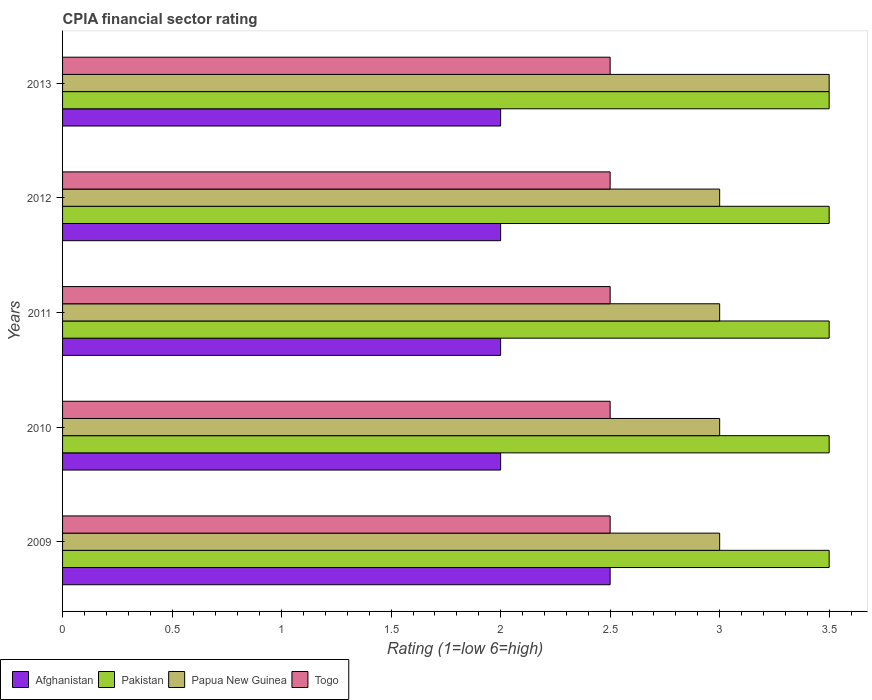How many different coloured bars are there?
Keep it short and to the point. 4. Are the number of bars per tick equal to the number of legend labels?
Offer a very short reply. Yes. Are the number of bars on each tick of the Y-axis equal?
Make the answer very short. Yes. How many bars are there on the 4th tick from the bottom?
Offer a very short reply. 4. Across all years, what is the maximum CPIA rating in Pakistan?
Provide a succinct answer. 3.5. Across all years, what is the minimum CPIA rating in Papua New Guinea?
Provide a short and direct response. 3. In which year was the CPIA rating in Afghanistan minimum?
Offer a terse response. 2010. What is the total CPIA rating in Papua New Guinea in the graph?
Offer a terse response. 15.5. What is the average CPIA rating in Afghanistan per year?
Ensure brevity in your answer.  2.1. What is the ratio of the CPIA rating in Togo in 2012 to that in 2013?
Make the answer very short. 1. Is the difference between the CPIA rating in Pakistan in 2009 and 2011 greater than the difference between the CPIA rating in Papua New Guinea in 2009 and 2011?
Ensure brevity in your answer.  No. What is the difference between the highest and the second highest CPIA rating in Papua New Guinea?
Offer a very short reply. 0.5. In how many years, is the CPIA rating in Afghanistan greater than the average CPIA rating in Afghanistan taken over all years?
Make the answer very short. 1. Is the sum of the CPIA rating in Papua New Guinea in 2009 and 2012 greater than the maximum CPIA rating in Pakistan across all years?
Give a very brief answer. Yes. Is it the case that in every year, the sum of the CPIA rating in Togo and CPIA rating in Pakistan is greater than the sum of CPIA rating in Afghanistan and CPIA rating in Papua New Guinea?
Provide a succinct answer. No. What does the 1st bar from the top in 2013 represents?
Keep it short and to the point. Togo. What does the 4th bar from the bottom in 2010 represents?
Ensure brevity in your answer.  Togo. How many bars are there?
Your response must be concise. 20. What is the difference between two consecutive major ticks on the X-axis?
Provide a short and direct response. 0.5. How many legend labels are there?
Make the answer very short. 4. How are the legend labels stacked?
Your response must be concise. Horizontal. What is the title of the graph?
Offer a very short reply. CPIA financial sector rating. Does "Poland" appear as one of the legend labels in the graph?
Give a very brief answer. No. What is the label or title of the Y-axis?
Provide a short and direct response. Years. What is the Rating (1=low 6=high) in Pakistan in 2009?
Make the answer very short. 3.5. What is the Rating (1=low 6=high) in Papua New Guinea in 2009?
Ensure brevity in your answer.  3. What is the Rating (1=low 6=high) in Afghanistan in 2010?
Your answer should be compact. 2. What is the Rating (1=low 6=high) of Togo in 2010?
Keep it short and to the point. 2.5. What is the Rating (1=low 6=high) of Togo in 2011?
Provide a succinct answer. 2.5. What is the Rating (1=low 6=high) of Pakistan in 2012?
Your answer should be very brief. 3.5. What is the Rating (1=low 6=high) of Togo in 2012?
Ensure brevity in your answer.  2.5. What is the Rating (1=low 6=high) in Afghanistan in 2013?
Give a very brief answer. 2. What is the Rating (1=low 6=high) in Pakistan in 2013?
Your response must be concise. 3.5. Across all years, what is the maximum Rating (1=low 6=high) in Pakistan?
Your answer should be very brief. 3.5. Across all years, what is the maximum Rating (1=low 6=high) of Togo?
Provide a short and direct response. 2.5. Across all years, what is the minimum Rating (1=low 6=high) in Afghanistan?
Provide a short and direct response. 2. Across all years, what is the minimum Rating (1=low 6=high) in Pakistan?
Offer a terse response. 3.5. Across all years, what is the minimum Rating (1=low 6=high) in Papua New Guinea?
Provide a succinct answer. 3. Across all years, what is the minimum Rating (1=low 6=high) in Togo?
Provide a succinct answer. 2.5. What is the total Rating (1=low 6=high) in Togo in the graph?
Give a very brief answer. 12.5. What is the difference between the Rating (1=low 6=high) in Afghanistan in 2009 and that in 2010?
Keep it short and to the point. 0.5. What is the difference between the Rating (1=low 6=high) of Afghanistan in 2009 and that in 2011?
Offer a very short reply. 0.5. What is the difference between the Rating (1=low 6=high) in Papua New Guinea in 2009 and that in 2011?
Make the answer very short. 0. What is the difference between the Rating (1=low 6=high) of Pakistan in 2009 and that in 2012?
Make the answer very short. 0. What is the difference between the Rating (1=low 6=high) of Papua New Guinea in 2009 and that in 2012?
Provide a short and direct response. 0. What is the difference between the Rating (1=low 6=high) of Afghanistan in 2009 and that in 2013?
Keep it short and to the point. 0.5. What is the difference between the Rating (1=low 6=high) of Papua New Guinea in 2009 and that in 2013?
Give a very brief answer. -0.5. What is the difference between the Rating (1=low 6=high) of Togo in 2009 and that in 2013?
Give a very brief answer. 0. What is the difference between the Rating (1=low 6=high) in Afghanistan in 2010 and that in 2011?
Keep it short and to the point. 0. What is the difference between the Rating (1=low 6=high) in Pakistan in 2010 and that in 2011?
Your answer should be very brief. 0. What is the difference between the Rating (1=low 6=high) in Papua New Guinea in 2010 and that in 2011?
Offer a terse response. 0. What is the difference between the Rating (1=low 6=high) of Pakistan in 2010 and that in 2012?
Your response must be concise. 0. What is the difference between the Rating (1=low 6=high) of Pakistan in 2010 and that in 2013?
Give a very brief answer. 0. What is the difference between the Rating (1=low 6=high) of Togo in 2010 and that in 2013?
Offer a very short reply. 0. What is the difference between the Rating (1=low 6=high) in Afghanistan in 2011 and that in 2012?
Your response must be concise. 0. What is the difference between the Rating (1=low 6=high) of Papua New Guinea in 2011 and that in 2012?
Provide a succinct answer. 0. What is the difference between the Rating (1=low 6=high) in Papua New Guinea in 2011 and that in 2013?
Provide a succinct answer. -0.5. What is the difference between the Rating (1=low 6=high) of Afghanistan in 2012 and that in 2013?
Give a very brief answer. 0. What is the difference between the Rating (1=low 6=high) of Afghanistan in 2009 and the Rating (1=low 6=high) of Pakistan in 2010?
Your answer should be very brief. -1. What is the difference between the Rating (1=low 6=high) of Afghanistan in 2009 and the Rating (1=low 6=high) of Papua New Guinea in 2010?
Ensure brevity in your answer.  -0.5. What is the difference between the Rating (1=low 6=high) of Papua New Guinea in 2009 and the Rating (1=low 6=high) of Togo in 2010?
Provide a succinct answer. 0.5. What is the difference between the Rating (1=low 6=high) of Afghanistan in 2009 and the Rating (1=low 6=high) of Pakistan in 2011?
Provide a short and direct response. -1. What is the difference between the Rating (1=low 6=high) in Afghanistan in 2009 and the Rating (1=low 6=high) in Papua New Guinea in 2011?
Provide a short and direct response. -0.5. What is the difference between the Rating (1=low 6=high) in Pakistan in 2009 and the Rating (1=low 6=high) in Togo in 2011?
Provide a succinct answer. 1. What is the difference between the Rating (1=low 6=high) of Papua New Guinea in 2009 and the Rating (1=low 6=high) of Togo in 2011?
Provide a short and direct response. 0.5. What is the difference between the Rating (1=low 6=high) of Afghanistan in 2009 and the Rating (1=low 6=high) of Papua New Guinea in 2012?
Keep it short and to the point. -0.5. What is the difference between the Rating (1=low 6=high) of Pakistan in 2009 and the Rating (1=low 6=high) of Togo in 2012?
Provide a short and direct response. 1. What is the difference between the Rating (1=low 6=high) of Papua New Guinea in 2009 and the Rating (1=low 6=high) of Togo in 2012?
Make the answer very short. 0.5. What is the difference between the Rating (1=low 6=high) in Afghanistan in 2009 and the Rating (1=low 6=high) in Togo in 2013?
Offer a very short reply. 0. What is the difference between the Rating (1=low 6=high) in Pakistan in 2009 and the Rating (1=low 6=high) in Papua New Guinea in 2013?
Provide a short and direct response. 0. What is the difference between the Rating (1=low 6=high) of Pakistan in 2009 and the Rating (1=low 6=high) of Togo in 2013?
Offer a very short reply. 1. What is the difference between the Rating (1=low 6=high) of Afghanistan in 2010 and the Rating (1=low 6=high) of Pakistan in 2011?
Give a very brief answer. -1.5. What is the difference between the Rating (1=low 6=high) in Afghanistan in 2010 and the Rating (1=low 6=high) in Togo in 2011?
Keep it short and to the point. -0.5. What is the difference between the Rating (1=low 6=high) in Pakistan in 2010 and the Rating (1=low 6=high) in Papua New Guinea in 2011?
Make the answer very short. 0.5. What is the difference between the Rating (1=low 6=high) in Pakistan in 2010 and the Rating (1=low 6=high) in Togo in 2011?
Your answer should be very brief. 1. What is the difference between the Rating (1=low 6=high) in Afghanistan in 2010 and the Rating (1=low 6=high) in Pakistan in 2012?
Offer a very short reply. -1.5. What is the difference between the Rating (1=low 6=high) in Pakistan in 2010 and the Rating (1=low 6=high) in Papua New Guinea in 2012?
Provide a succinct answer. 0.5. What is the difference between the Rating (1=low 6=high) of Afghanistan in 2010 and the Rating (1=low 6=high) of Papua New Guinea in 2013?
Your answer should be very brief. -1.5. What is the difference between the Rating (1=low 6=high) in Afghanistan in 2010 and the Rating (1=low 6=high) in Togo in 2013?
Provide a short and direct response. -0.5. What is the difference between the Rating (1=low 6=high) of Pakistan in 2010 and the Rating (1=low 6=high) of Papua New Guinea in 2013?
Make the answer very short. 0. What is the difference between the Rating (1=low 6=high) in Afghanistan in 2011 and the Rating (1=low 6=high) in Papua New Guinea in 2012?
Offer a very short reply. -1. What is the difference between the Rating (1=low 6=high) in Afghanistan in 2011 and the Rating (1=low 6=high) in Togo in 2012?
Make the answer very short. -0.5. What is the difference between the Rating (1=low 6=high) in Pakistan in 2011 and the Rating (1=low 6=high) in Togo in 2012?
Ensure brevity in your answer.  1. What is the difference between the Rating (1=low 6=high) in Papua New Guinea in 2011 and the Rating (1=low 6=high) in Togo in 2012?
Provide a succinct answer. 0.5. What is the difference between the Rating (1=low 6=high) in Afghanistan in 2011 and the Rating (1=low 6=high) in Papua New Guinea in 2013?
Make the answer very short. -1.5. What is the difference between the Rating (1=low 6=high) in Afghanistan in 2011 and the Rating (1=low 6=high) in Togo in 2013?
Make the answer very short. -0.5. What is the difference between the Rating (1=low 6=high) of Pakistan in 2011 and the Rating (1=low 6=high) of Togo in 2013?
Offer a very short reply. 1. What is the difference between the Rating (1=low 6=high) in Afghanistan in 2012 and the Rating (1=low 6=high) in Papua New Guinea in 2013?
Provide a succinct answer. -1.5. What is the difference between the Rating (1=low 6=high) of Afghanistan in 2012 and the Rating (1=low 6=high) of Togo in 2013?
Offer a terse response. -0.5. What is the difference between the Rating (1=low 6=high) in Pakistan in 2012 and the Rating (1=low 6=high) in Togo in 2013?
Offer a very short reply. 1. What is the average Rating (1=low 6=high) in Afghanistan per year?
Your response must be concise. 2.1. In the year 2009, what is the difference between the Rating (1=low 6=high) of Papua New Guinea and Rating (1=low 6=high) of Togo?
Make the answer very short. 0.5. In the year 2010, what is the difference between the Rating (1=low 6=high) in Afghanistan and Rating (1=low 6=high) in Papua New Guinea?
Offer a very short reply. -1. In the year 2010, what is the difference between the Rating (1=low 6=high) in Afghanistan and Rating (1=low 6=high) in Togo?
Your answer should be very brief. -0.5. In the year 2010, what is the difference between the Rating (1=low 6=high) of Pakistan and Rating (1=low 6=high) of Papua New Guinea?
Offer a terse response. 0.5. In the year 2011, what is the difference between the Rating (1=low 6=high) in Afghanistan and Rating (1=low 6=high) in Papua New Guinea?
Provide a succinct answer. -1. In the year 2011, what is the difference between the Rating (1=low 6=high) in Afghanistan and Rating (1=low 6=high) in Togo?
Your response must be concise. -0.5. In the year 2011, what is the difference between the Rating (1=low 6=high) in Pakistan and Rating (1=low 6=high) in Togo?
Offer a very short reply. 1. In the year 2011, what is the difference between the Rating (1=low 6=high) in Papua New Guinea and Rating (1=low 6=high) in Togo?
Ensure brevity in your answer.  0.5. In the year 2012, what is the difference between the Rating (1=low 6=high) in Afghanistan and Rating (1=low 6=high) in Pakistan?
Ensure brevity in your answer.  -1.5. In the year 2012, what is the difference between the Rating (1=low 6=high) in Afghanistan and Rating (1=low 6=high) in Papua New Guinea?
Your answer should be compact. -1. In the year 2012, what is the difference between the Rating (1=low 6=high) in Pakistan and Rating (1=low 6=high) in Togo?
Give a very brief answer. 1. In the year 2013, what is the difference between the Rating (1=low 6=high) in Afghanistan and Rating (1=low 6=high) in Pakistan?
Your answer should be compact. -1.5. In the year 2013, what is the difference between the Rating (1=low 6=high) in Afghanistan and Rating (1=low 6=high) in Papua New Guinea?
Your answer should be very brief. -1.5. In the year 2013, what is the difference between the Rating (1=low 6=high) in Afghanistan and Rating (1=low 6=high) in Togo?
Give a very brief answer. -0.5. In the year 2013, what is the difference between the Rating (1=low 6=high) of Pakistan and Rating (1=low 6=high) of Papua New Guinea?
Ensure brevity in your answer.  0. In the year 2013, what is the difference between the Rating (1=low 6=high) in Pakistan and Rating (1=low 6=high) in Togo?
Offer a very short reply. 1. In the year 2013, what is the difference between the Rating (1=low 6=high) of Papua New Guinea and Rating (1=low 6=high) of Togo?
Make the answer very short. 1. What is the ratio of the Rating (1=low 6=high) in Afghanistan in 2009 to that in 2010?
Provide a short and direct response. 1.25. What is the ratio of the Rating (1=low 6=high) in Papua New Guinea in 2009 to that in 2010?
Ensure brevity in your answer.  1. What is the ratio of the Rating (1=low 6=high) in Afghanistan in 2009 to that in 2011?
Provide a short and direct response. 1.25. What is the ratio of the Rating (1=low 6=high) in Pakistan in 2009 to that in 2011?
Give a very brief answer. 1. What is the ratio of the Rating (1=low 6=high) of Togo in 2009 to that in 2012?
Provide a short and direct response. 1. What is the ratio of the Rating (1=low 6=high) in Pakistan in 2009 to that in 2013?
Give a very brief answer. 1. What is the ratio of the Rating (1=low 6=high) of Afghanistan in 2010 to that in 2011?
Give a very brief answer. 1. What is the ratio of the Rating (1=low 6=high) of Pakistan in 2010 to that in 2011?
Your answer should be compact. 1. What is the ratio of the Rating (1=low 6=high) in Papua New Guinea in 2010 to that in 2011?
Your response must be concise. 1. What is the ratio of the Rating (1=low 6=high) in Togo in 2010 to that in 2011?
Offer a very short reply. 1. What is the ratio of the Rating (1=low 6=high) in Papua New Guinea in 2010 to that in 2012?
Your answer should be compact. 1. What is the ratio of the Rating (1=low 6=high) in Afghanistan in 2010 to that in 2013?
Your answer should be very brief. 1. What is the ratio of the Rating (1=low 6=high) of Pakistan in 2010 to that in 2013?
Keep it short and to the point. 1. What is the ratio of the Rating (1=low 6=high) in Papua New Guinea in 2010 to that in 2013?
Offer a terse response. 0.86. What is the ratio of the Rating (1=low 6=high) in Afghanistan in 2011 to that in 2012?
Your answer should be compact. 1. What is the ratio of the Rating (1=low 6=high) in Pakistan in 2011 to that in 2012?
Offer a terse response. 1. What is the ratio of the Rating (1=low 6=high) of Papua New Guinea in 2011 to that in 2012?
Ensure brevity in your answer.  1. What is the ratio of the Rating (1=low 6=high) in Togo in 2011 to that in 2012?
Offer a terse response. 1. What is the ratio of the Rating (1=low 6=high) in Afghanistan in 2011 to that in 2013?
Provide a succinct answer. 1. What is the ratio of the Rating (1=low 6=high) in Pakistan in 2011 to that in 2013?
Provide a succinct answer. 1. What is the ratio of the Rating (1=low 6=high) in Afghanistan in 2012 to that in 2013?
Your answer should be compact. 1. What is the difference between the highest and the second highest Rating (1=low 6=high) of Pakistan?
Provide a succinct answer. 0. What is the difference between the highest and the second highest Rating (1=low 6=high) of Papua New Guinea?
Offer a very short reply. 0.5. What is the difference between the highest and the lowest Rating (1=low 6=high) of Pakistan?
Provide a short and direct response. 0. 